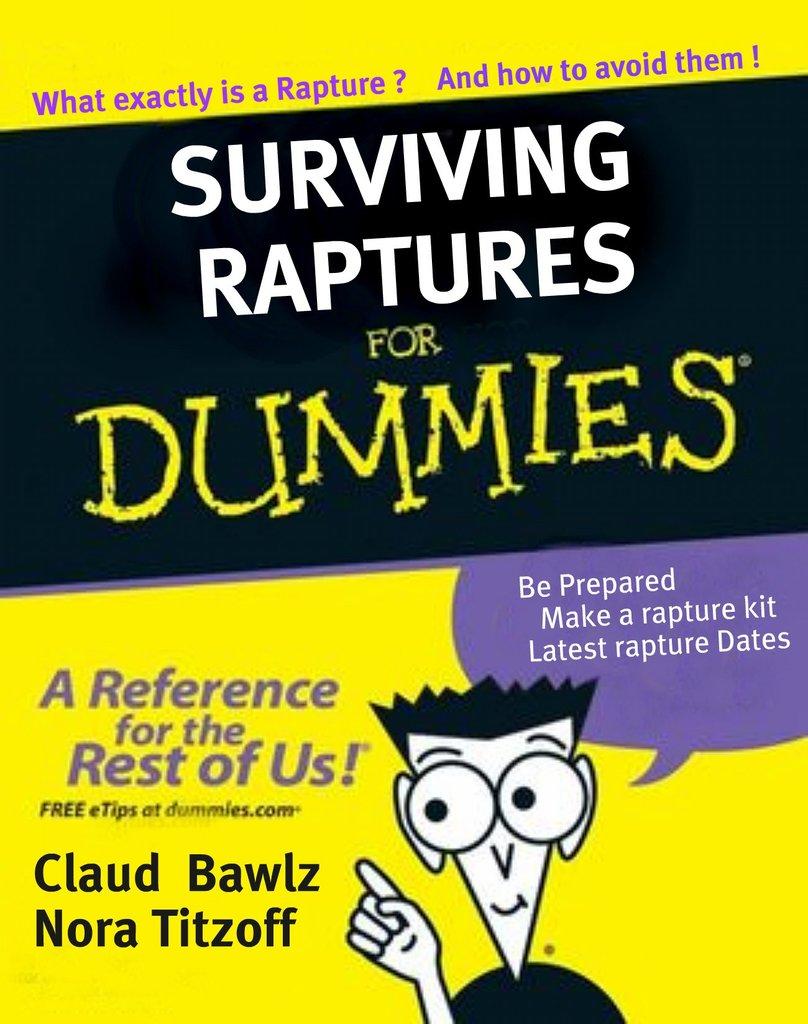What is the name of this book?
Provide a succinct answer. Surviving raptures for dummies. 